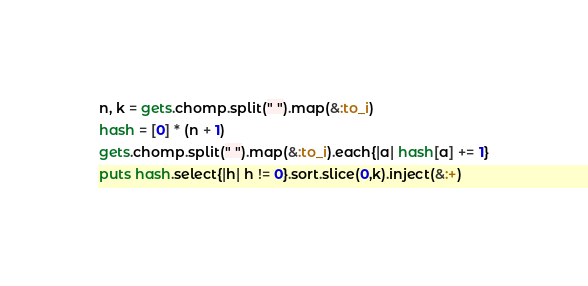Convert code to text. <code><loc_0><loc_0><loc_500><loc_500><_Ruby_>n, k = gets.chomp.split(" ").map(&:to_i)
hash = [0] * (n + 1)
gets.chomp.split(" ").map(&:to_i).each{|a| hash[a] += 1}
puts hash.select{|h| h != 0}.sort.slice(0,k).inject(&:+)
</code> 